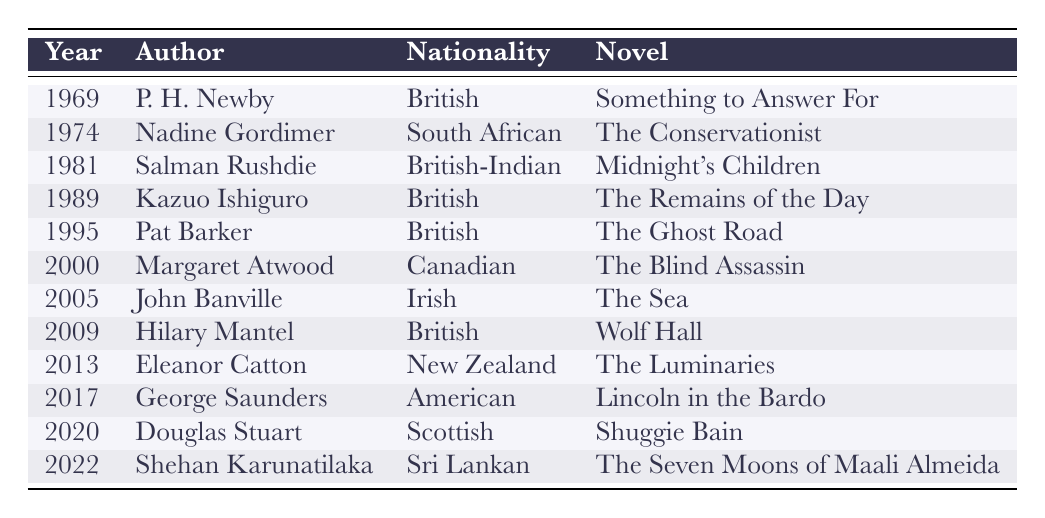What nationality is the author of "The Ghost Road"? The table indicates that the author of "The Ghost Road," Pat Barker, is British.
Answer: British How many authors are from British nationality in the table? The table lists Pat Barker, Kazuo Ishiguro, Hilary Mantel, and Salman Rushdie as British authors, totaling four.
Answer: 4 Did any author win the Booker Prize in 1995? Yes, Pat Barker won the Booker Prize in 1995 for "The Ghost Road."
Answer: Yes Which novel corresponds to the author George Saunders? The table shows that George Saunders wrote "Lincoln in the Bardo."
Answer: Lincoln in the Bardo What is the difference in years between the first and the last Booker Prize winners listed? The first Booker Prize winner listed is from 1969 and the last one is from 2022. The difference is 2022 - 1969 = 53 years.
Answer: 53 Which country has the author with the most recent win listed? The most recent author listed is Shehan Karunatilaka, who is from Sri Lanka and won in 2022.
Answer: Sri Lanka Are there any authors from African nationality in the list? Yes, there is an author from Africa: Nadine Gordimer, who is South African.
Answer: Yes Which nationality has the highest representation in the list? By counting the instances, British nationality appears most often, with four mentions compared to others.
Answer: British 